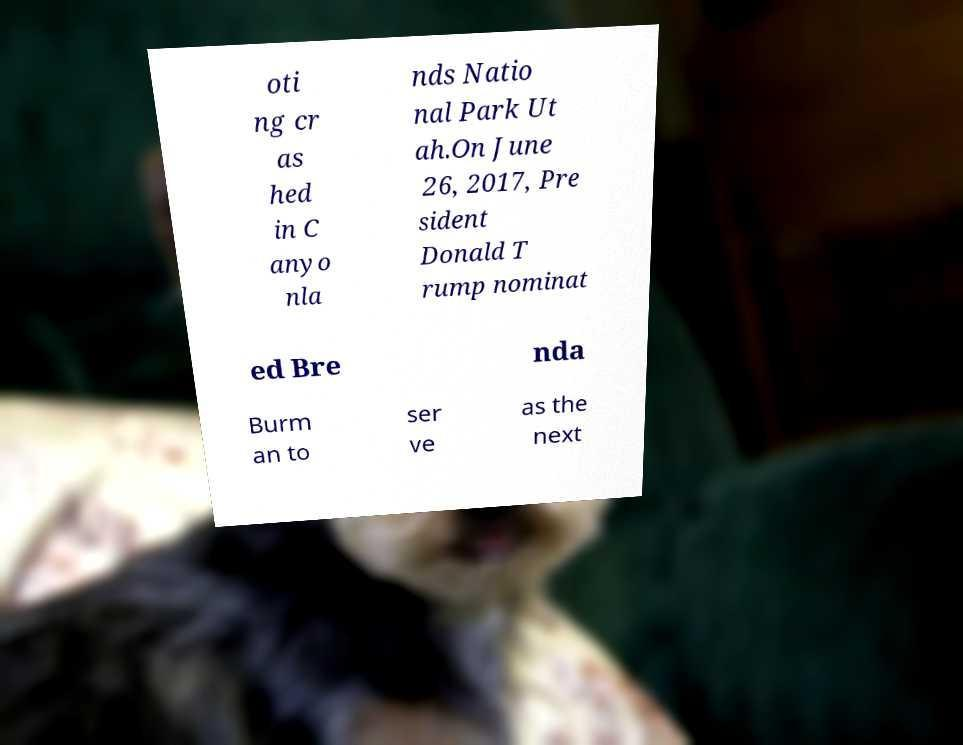Please read and relay the text visible in this image. What does it say? oti ng cr as hed in C anyo nla nds Natio nal Park Ut ah.On June 26, 2017, Pre sident Donald T rump nominat ed Bre nda Burm an to ser ve as the next 